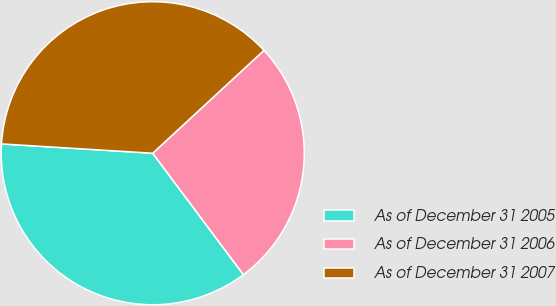Convert chart to OTSL. <chart><loc_0><loc_0><loc_500><loc_500><pie_chart><fcel>As of December 31 2005<fcel>As of December 31 2006<fcel>As of December 31 2007<nl><fcel>36.19%<fcel>26.67%<fcel>37.14%<nl></chart> 